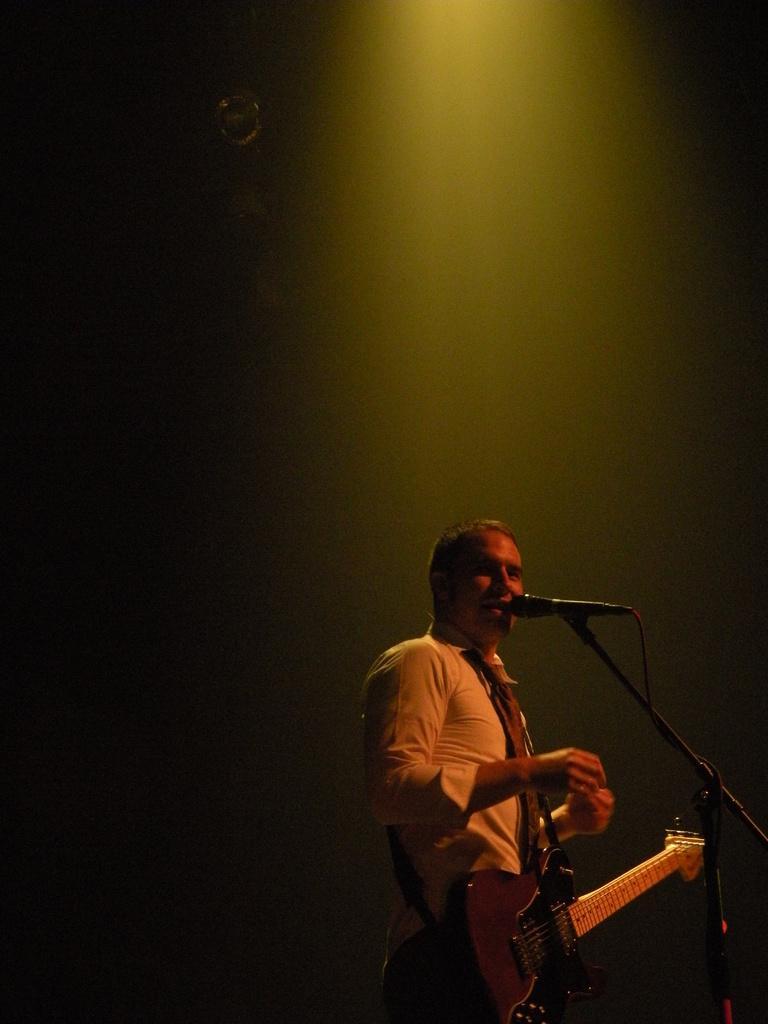Can you describe this image briefly? In this image there is a man standing on the stage and having a guitar. This is a mic in which he is singing a song. 